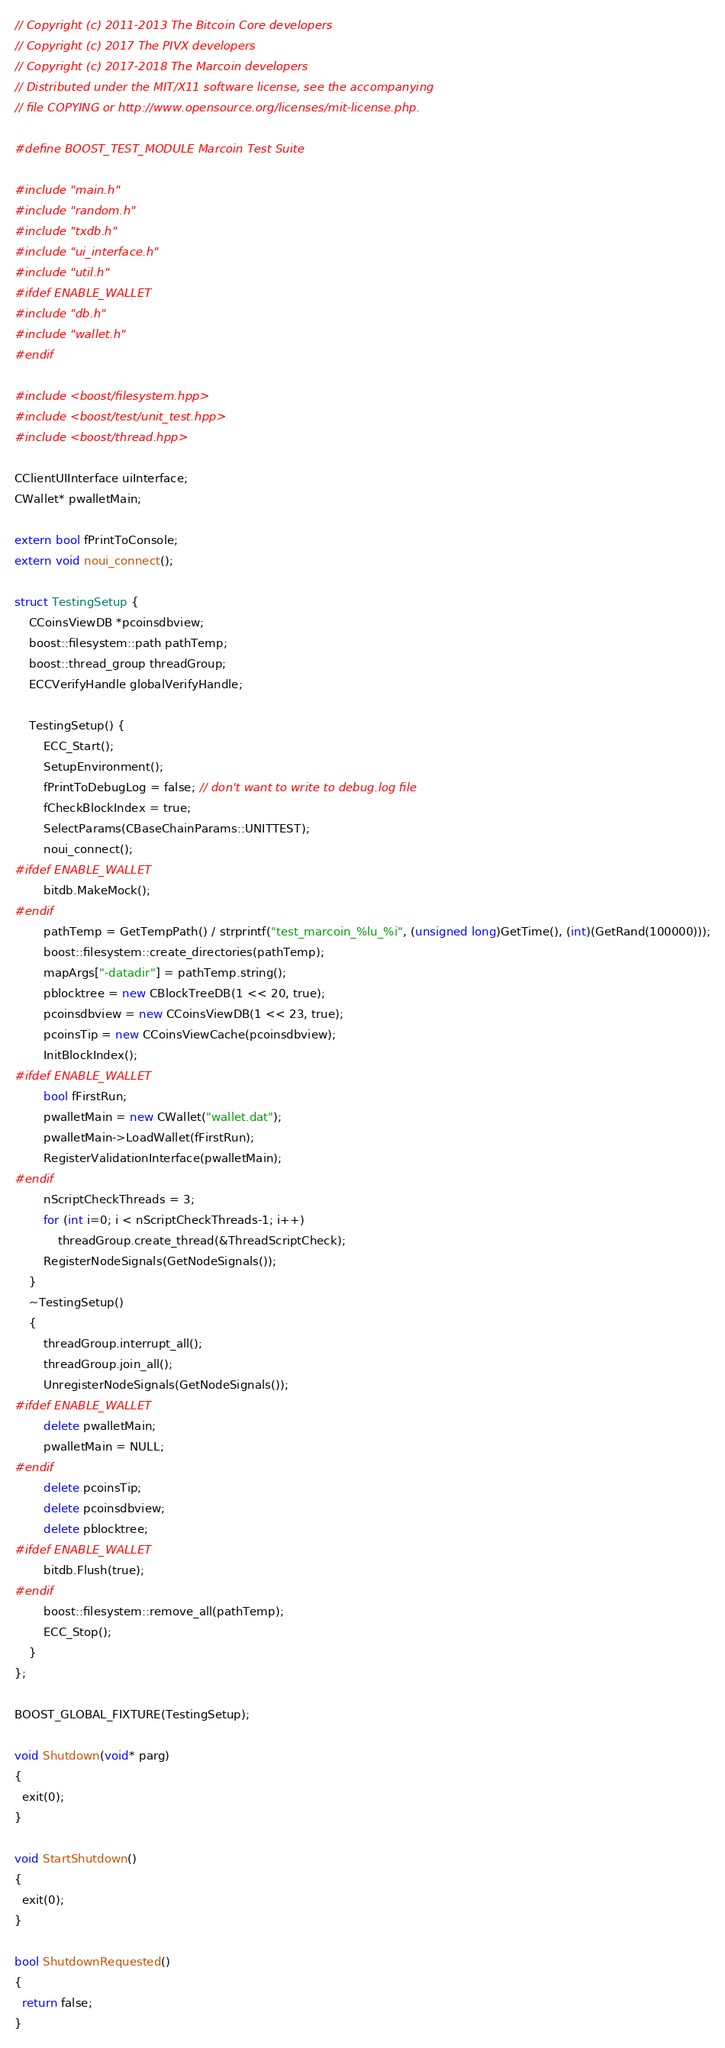Convert code to text. <code><loc_0><loc_0><loc_500><loc_500><_C++_>// Copyright (c) 2011-2013 The Bitcoin Core developers
// Copyright (c) 2017 The PIVX developers
// Copyright (c) 2017-2018 The Marcoin developers
// Distributed under the MIT/X11 software license, see the accompanying
// file COPYING or http://www.opensource.org/licenses/mit-license.php.

#define BOOST_TEST_MODULE Marcoin Test Suite

#include "main.h"
#include "random.h"
#include "txdb.h"
#include "ui_interface.h"
#include "util.h"
#ifdef ENABLE_WALLET
#include "db.h"
#include "wallet.h"
#endif

#include <boost/filesystem.hpp>
#include <boost/test/unit_test.hpp>
#include <boost/thread.hpp>

CClientUIInterface uiInterface;
CWallet* pwalletMain;

extern bool fPrintToConsole;
extern void noui_connect();

struct TestingSetup {
    CCoinsViewDB *pcoinsdbview;
    boost::filesystem::path pathTemp;
    boost::thread_group threadGroup;
    ECCVerifyHandle globalVerifyHandle;

    TestingSetup() {
        ECC_Start();
        SetupEnvironment();
        fPrintToDebugLog = false; // don't want to write to debug.log file
        fCheckBlockIndex = true;
        SelectParams(CBaseChainParams::UNITTEST);
        noui_connect();
#ifdef ENABLE_WALLET
        bitdb.MakeMock();
#endif
        pathTemp = GetTempPath() / strprintf("test_marcoin_%lu_%i", (unsigned long)GetTime(), (int)(GetRand(100000)));
        boost::filesystem::create_directories(pathTemp);
        mapArgs["-datadir"] = pathTemp.string();
        pblocktree = new CBlockTreeDB(1 << 20, true);
        pcoinsdbview = new CCoinsViewDB(1 << 23, true);
        pcoinsTip = new CCoinsViewCache(pcoinsdbview);
        InitBlockIndex();
#ifdef ENABLE_WALLET
        bool fFirstRun;
        pwalletMain = new CWallet("wallet.dat");
        pwalletMain->LoadWallet(fFirstRun);
        RegisterValidationInterface(pwalletMain);
#endif
        nScriptCheckThreads = 3;
        for (int i=0; i < nScriptCheckThreads-1; i++)
            threadGroup.create_thread(&ThreadScriptCheck);
        RegisterNodeSignals(GetNodeSignals());
    }
    ~TestingSetup()
    {
        threadGroup.interrupt_all();
        threadGroup.join_all();
        UnregisterNodeSignals(GetNodeSignals());
#ifdef ENABLE_WALLET
        delete pwalletMain;
        pwalletMain = NULL;
#endif
        delete pcoinsTip;
        delete pcoinsdbview;
        delete pblocktree;
#ifdef ENABLE_WALLET
        bitdb.Flush(true);
#endif
        boost::filesystem::remove_all(pathTemp);
        ECC_Stop();
    }
};

BOOST_GLOBAL_FIXTURE(TestingSetup);

void Shutdown(void* parg)
{
  exit(0);
}

void StartShutdown()
{
  exit(0);
}

bool ShutdownRequested()
{
  return false;
}
</code> 